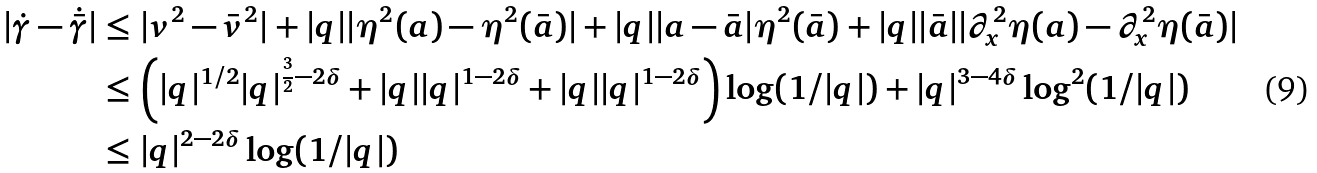<formula> <loc_0><loc_0><loc_500><loc_500>| \dot { \gamma } - \dot { \bar { \gamma } } | & \leq | v ^ { 2 } - \bar { v } ^ { 2 } | + | q | | \eta ^ { 2 } ( a ) - \eta ^ { 2 } ( \bar { a } ) | + | q | | a - \bar { a } | \eta ^ { 2 } ( \bar { a } ) + | q | | \bar { a } | | \partial _ { x } ^ { 2 } \eta ( a ) - \partial _ { x } ^ { 2 } \eta ( \bar { a } ) | \\ & \leq \left ( | q | ^ { 1 / 2 } | q | ^ { \frac { 3 } { 2 } - 2 \delta } + | q | | q | ^ { 1 - 2 \delta } + | q | | q | ^ { 1 - 2 \delta } \right ) \log ( 1 / | q | ) + | q | ^ { 3 - 4 \delta } \log ^ { 2 } ( 1 / | q | ) \\ & \leq | q | ^ { 2 - 2 \delta } \log ( 1 / | q | )</formula> 